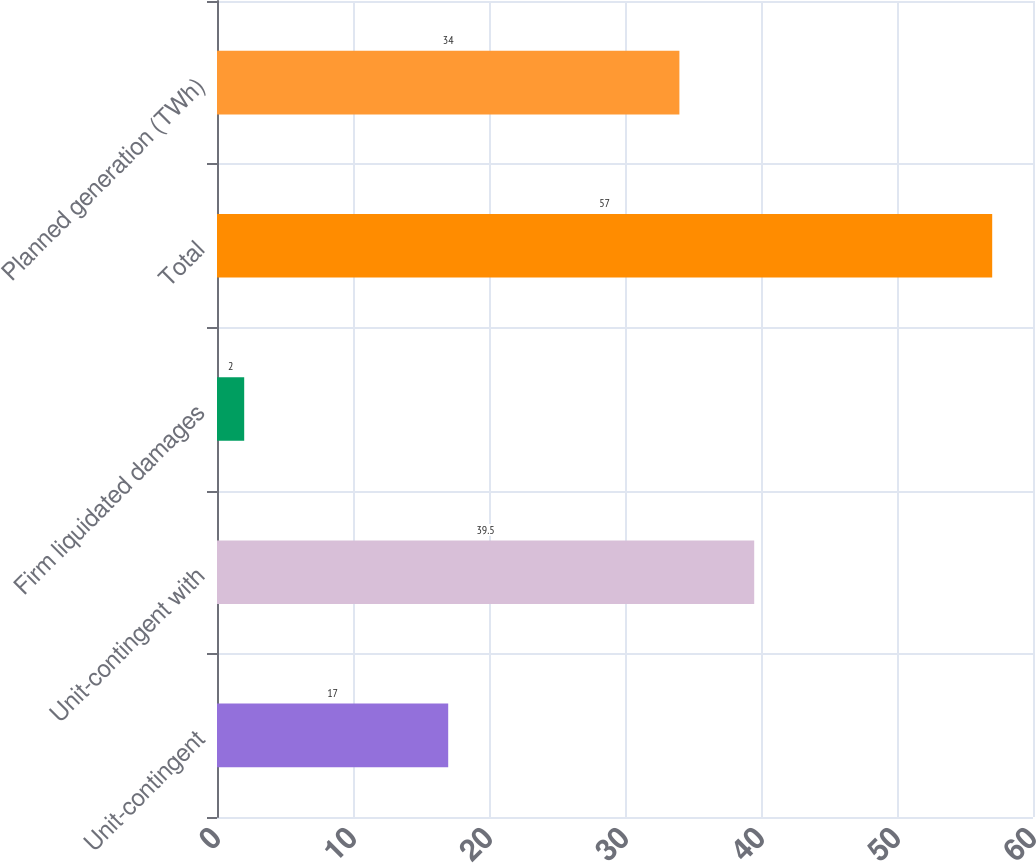<chart> <loc_0><loc_0><loc_500><loc_500><bar_chart><fcel>Unit-contingent<fcel>Unit-contingent with<fcel>Firm liquidated damages<fcel>Total<fcel>Planned generation (TWh)<nl><fcel>17<fcel>39.5<fcel>2<fcel>57<fcel>34<nl></chart> 